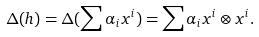Convert formula to latex. <formula><loc_0><loc_0><loc_500><loc_500>\Delta ( h ) = \Delta ( \sum \alpha _ { i } x ^ { i } ) = \sum \alpha _ { i } x ^ { i } \otimes x ^ { i } .</formula> 